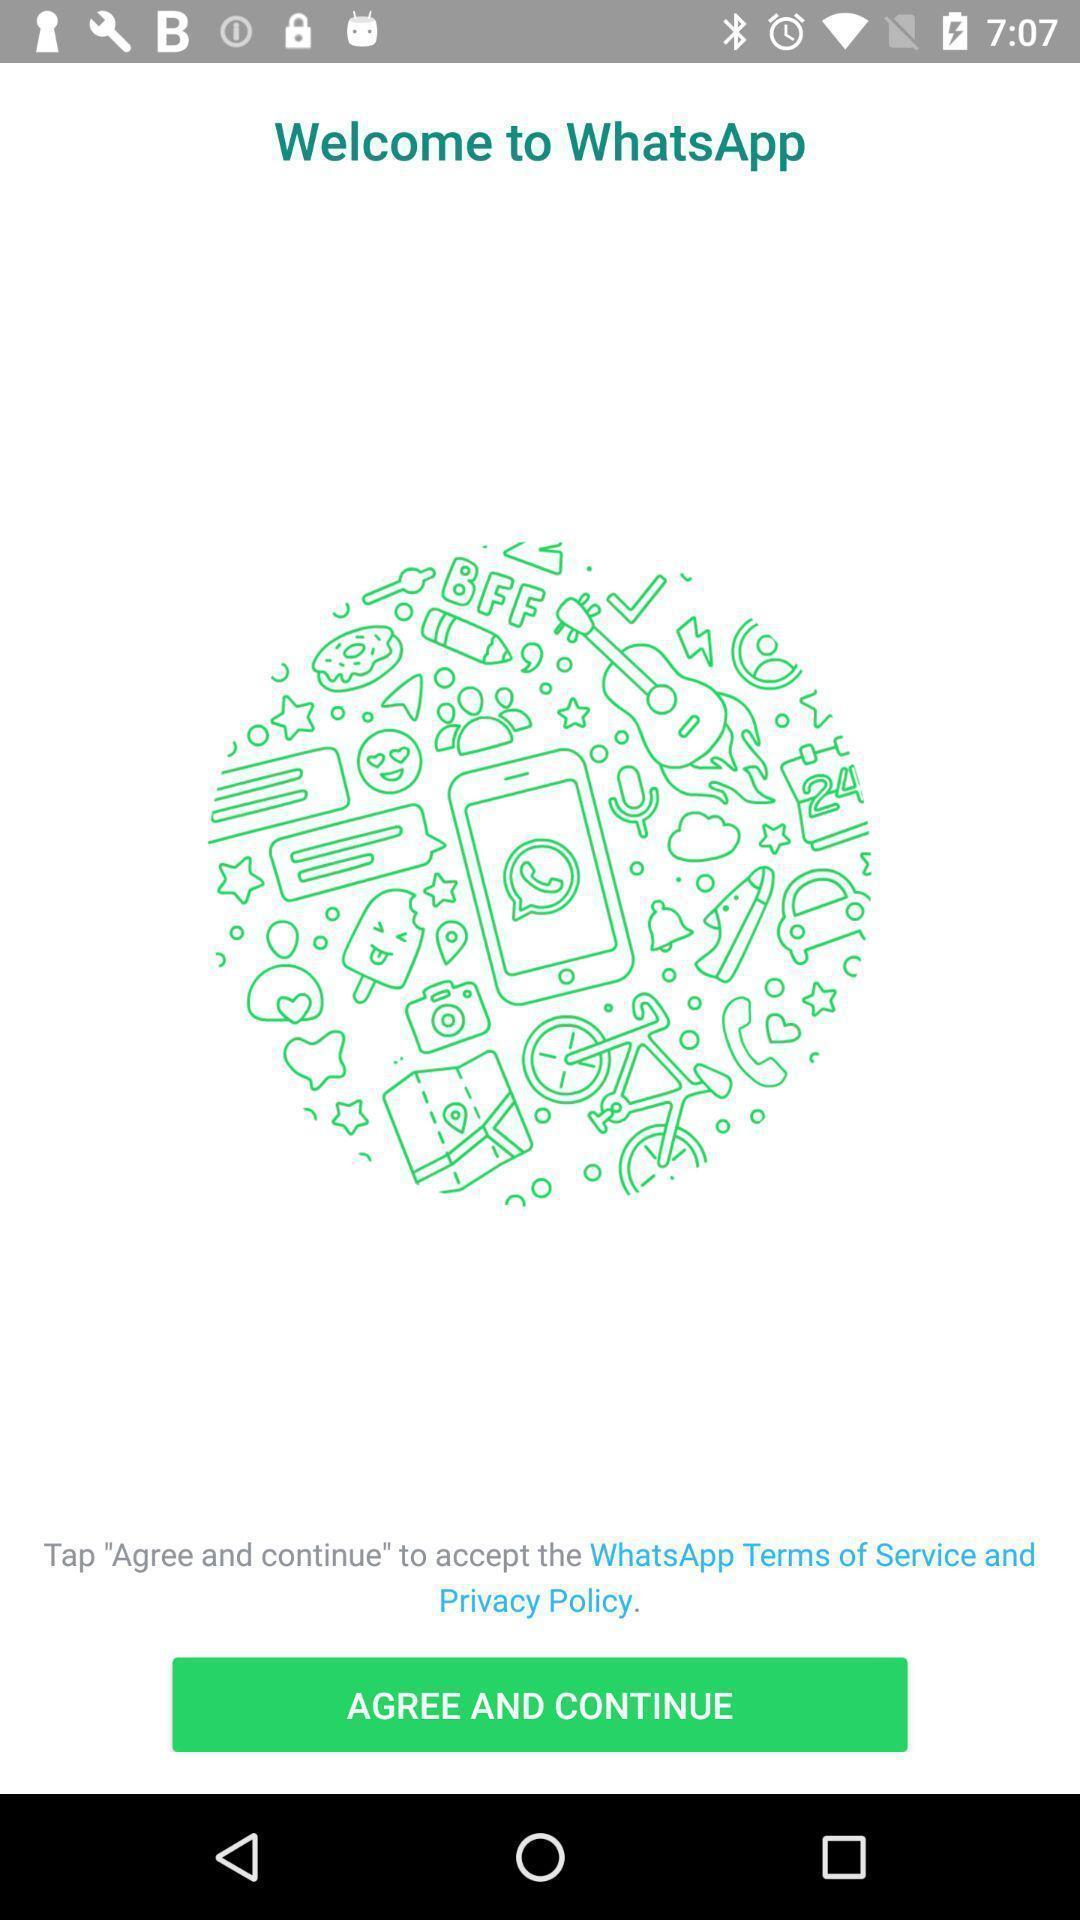What can you discern from this picture? Welcome page of application with agree and continue option. 